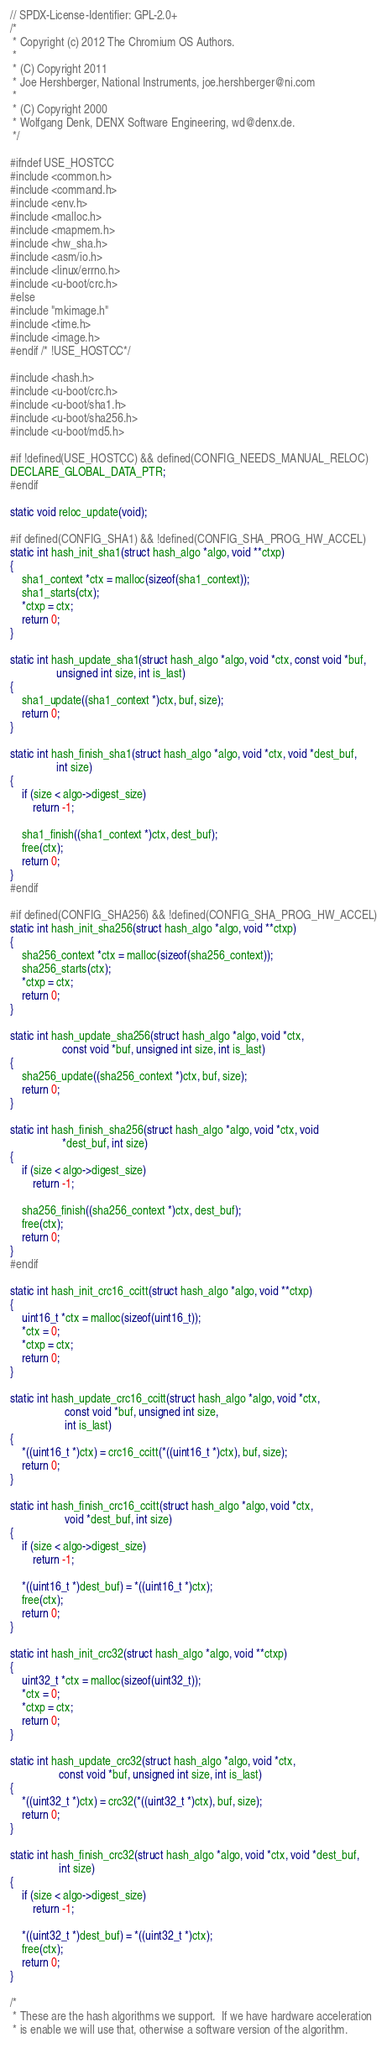<code> <loc_0><loc_0><loc_500><loc_500><_C_>// SPDX-License-Identifier: GPL-2.0+
/*
 * Copyright (c) 2012 The Chromium OS Authors.
 *
 * (C) Copyright 2011
 * Joe Hershberger, National Instruments, joe.hershberger@ni.com
 *
 * (C) Copyright 2000
 * Wolfgang Denk, DENX Software Engineering, wd@denx.de.
 */

#ifndef USE_HOSTCC
#include <common.h>
#include <command.h>
#include <env.h>
#include <malloc.h>
#include <mapmem.h>
#include <hw_sha.h>
#include <asm/io.h>
#include <linux/errno.h>
#include <u-boot/crc.h>
#else
#include "mkimage.h"
#include <time.h>
#include <image.h>
#endif /* !USE_HOSTCC*/

#include <hash.h>
#include <u-boot/crc.h>
#include <u-boot/sha1.h>
#include <u-boot/sha256.h>
#include <u-boot/md5.h>

#if !defined(USE_HOSTCC) && defined(CONFIG_NEEDS_MANUAL_RELOC)
DECLARE_GLOBAL_DATA_PTR;
#endif

static void reloc_update(void);

#if defined(CONFIG_SHA1) && !defined(CONFIG_SHA_PROG_HW_ACCEL)
static int hash_init_sha1(struct hash_algo *algo, void **ctxp)
{
	sha1_context *ctx = malloc(sizeof(sha1_context));
	sha1_starts(ctx);
	*ctxp = ctx;
	return 0;
}

static int hash_update_sha1(struct hash_algo *algo, void *ctx, const void *buf,
			    unsigned int size, int is_last)
{
	sha1_update((sha1_context *)ctx, buf, size);
	return 0;
}

static int hash_finish_sha1(struct hash_algo *algo, void *ctx, void *dest_buf,
			    int size)
{
	if (size < algo->digest_size)
		return -1;

	sha1_finish((sha1_context *)ctx, dest_buf);
	free(ctx);
	return 0;
}
#endif

#if defined(CONFIG_SHA256) && !defined(CONFIG_SHA_PROG_HW_ACCEL)
static int hash_init_sha256(struct hash_algo *algo, void **ctxp)
{
	sha256_context *ctx = malloc(sizeof(sha256_context));
	sha256_starts(ctx);
	*ctxp = ctx;
	return 0;
}

static int hash_update_sha256(struct hash_algo *algo, void *ctx,
			      const void *buf, unsigned int size, int is_last)
{
	sha256_update((sha256_context *)ctx, buf, size);
	return 0;
}

static int hash_finish_sha256(struct hash_algo *algo, void *ctx, void
			      *dest_buf, int size)
{
	if (size < algo->digest_size)
		return -1;

	sha256_finish((sha256_context *)ctx, dest_buf);
	free(ctx);
	return 0;
}
#endif

static int hash_init_crc16_ccitt(struct hash_algo *algo, void **ctxp)
{
	uint16_t *ctx = malloc(sizeof(uint16_t));
	*ctx = 0;
	*ctxp = ctx;
	return 0;
}

static int hash_update_crc16_ccitt(struct hash_algo *algo, void *ctx,
				   const void *buf, unsigned int size,
				   int is_last)
{
	*((uint16_t *)ctx) = crc16_ccitt(*((uint16_t *)ctx), buf, size);
	return 0;
}

static int hash_finish_crc16_ccitt(struct hash_algo *algo, void *ctx,
				   void *dest_buf, int size)
{
	if (size < algo->digest_size)
		return -1;

	*((uint16_t *)dest_buf) = *((uint16_t *)ctx);
	free(ctx);
	return 0;
}

static int hash_init_crc32(struct hash_algo *algo, void **ctxp)
{
	uint32_t *ctx = malloc(sizeof(uint32_t));
	*ctx = 0;
	*ctxp = ctx;
	return 0;
}

static int hash_update_crc32(struct hash_algo *algo, void *ctx,
			     const void *buf, unsigned int size, int is_last)
{
	*((uint32_t *)ctx) = crc32(*((uint32_t *)ctx), buf, size);
	return 0;
}

static int hash_finish_crc32(struct hash_algo *algo, void *ctx, void *dest_buf,
			     int size)
{
	if (size < algo->digest_size)
		return -1;

	*((uint32_t *)dest_buf) = *((uint32_t *)ctx);
	free(ctx);
	return 0;
}

/*
 * These are the hash algorithms we support.  If we have hardware acceleration
 * is enable we will use that, otherwise a software version of the algorithm.</code> 